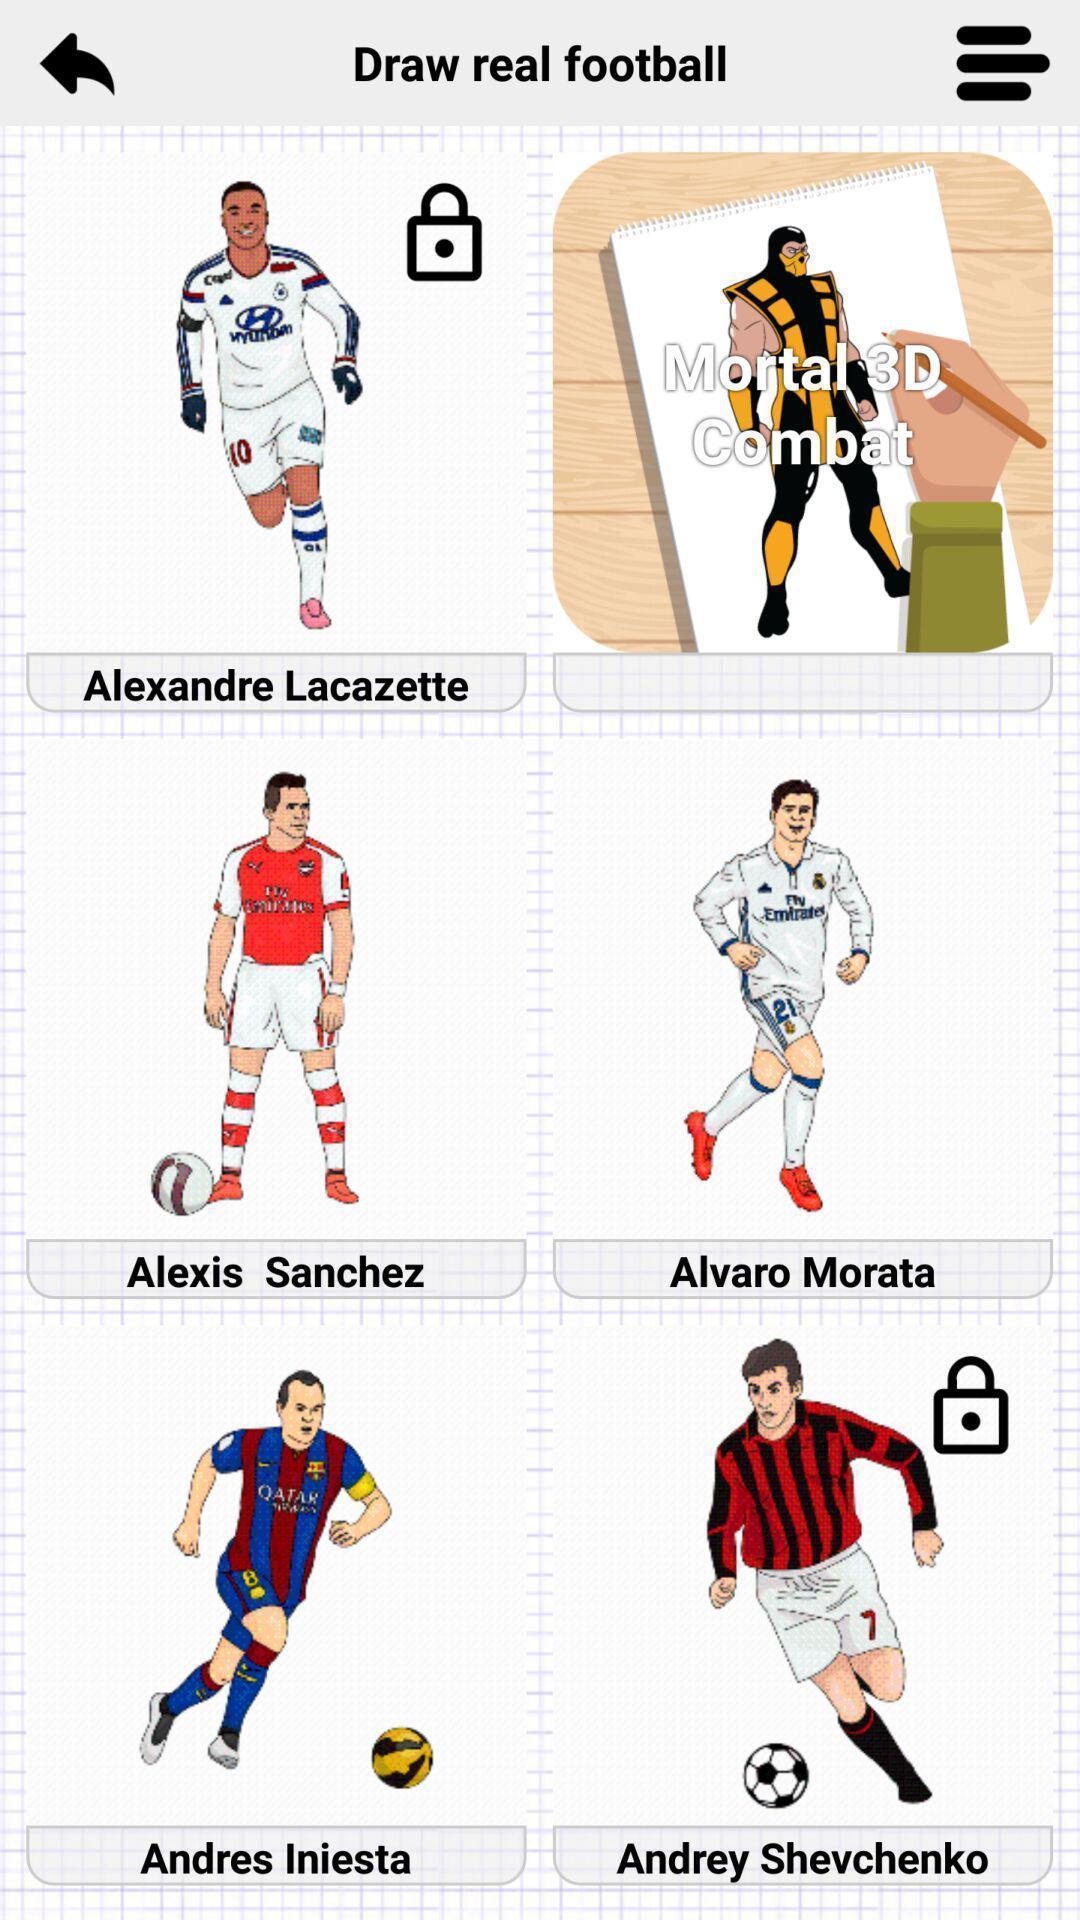Explain what's happening in this screen capture. Page showing different images on an app. 